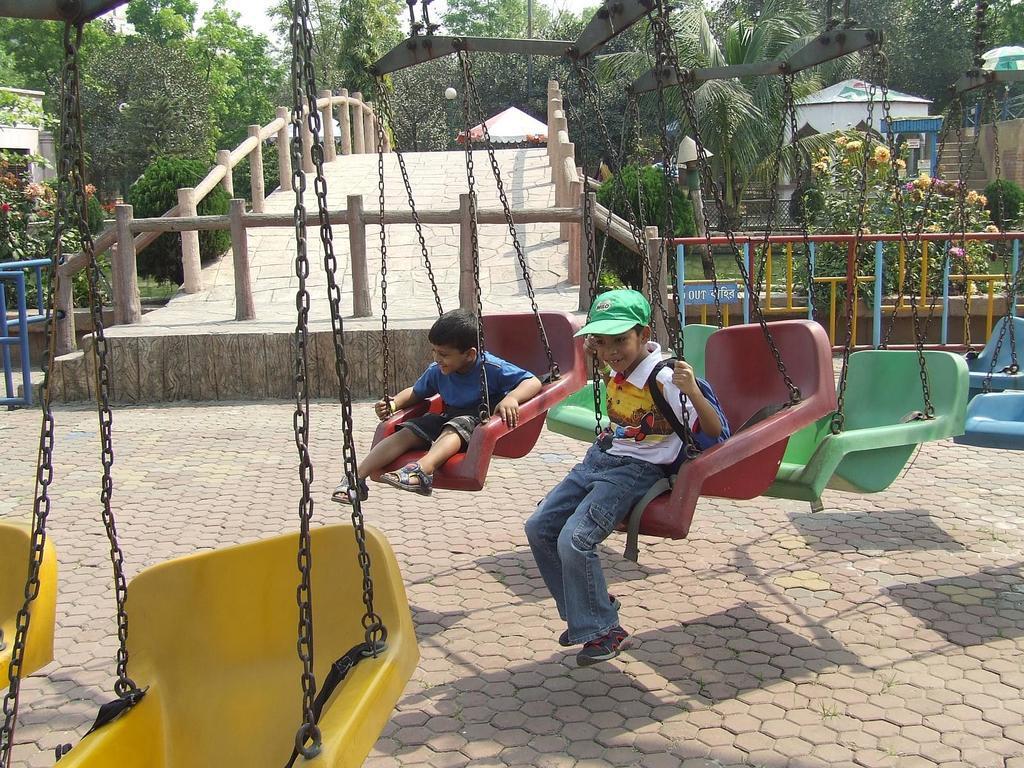Please provide a concise description of this image. In this image there are two children sitting on the swings, behind them there is a wooden bridge. On the right and left side of the bridge there are trees, plants, flowers and the surface of the grass. 